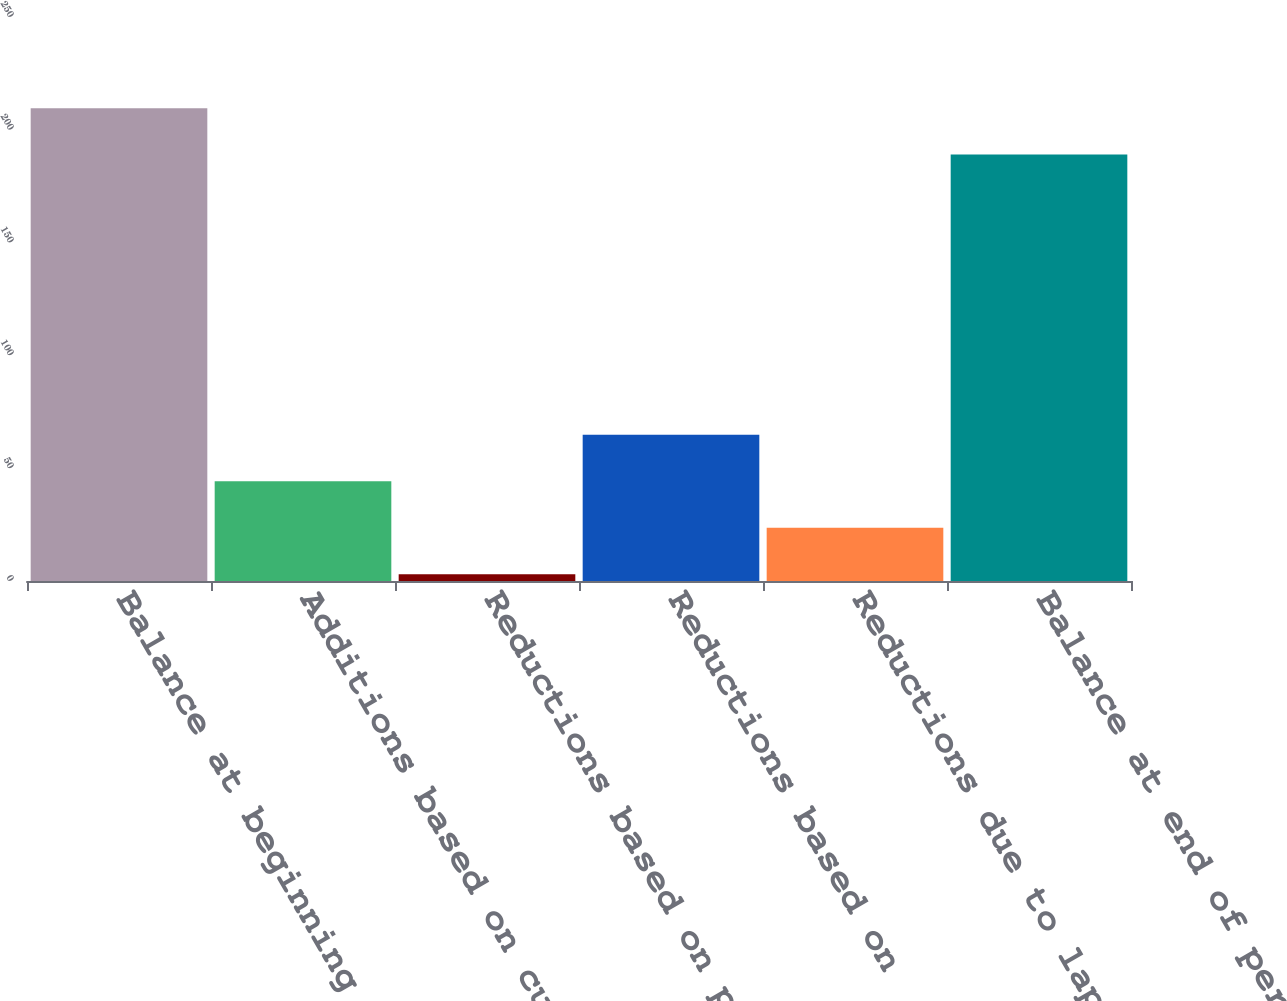<chart> <loc_0><loc_0><loc_500><loc_500><bar_chart><fcel>Balance at beginning of period<fcel>Additions based on current<fcel>Reductions based on prior year<fcel>Reductions based on<fcel>Reductions due to lapse in<fcel>Balance at end of period<nl><fcel>209.6<fcel>44.2<fcel>3<fcel>64.8<fcel>23.6<fcel>189<nl></chart> 